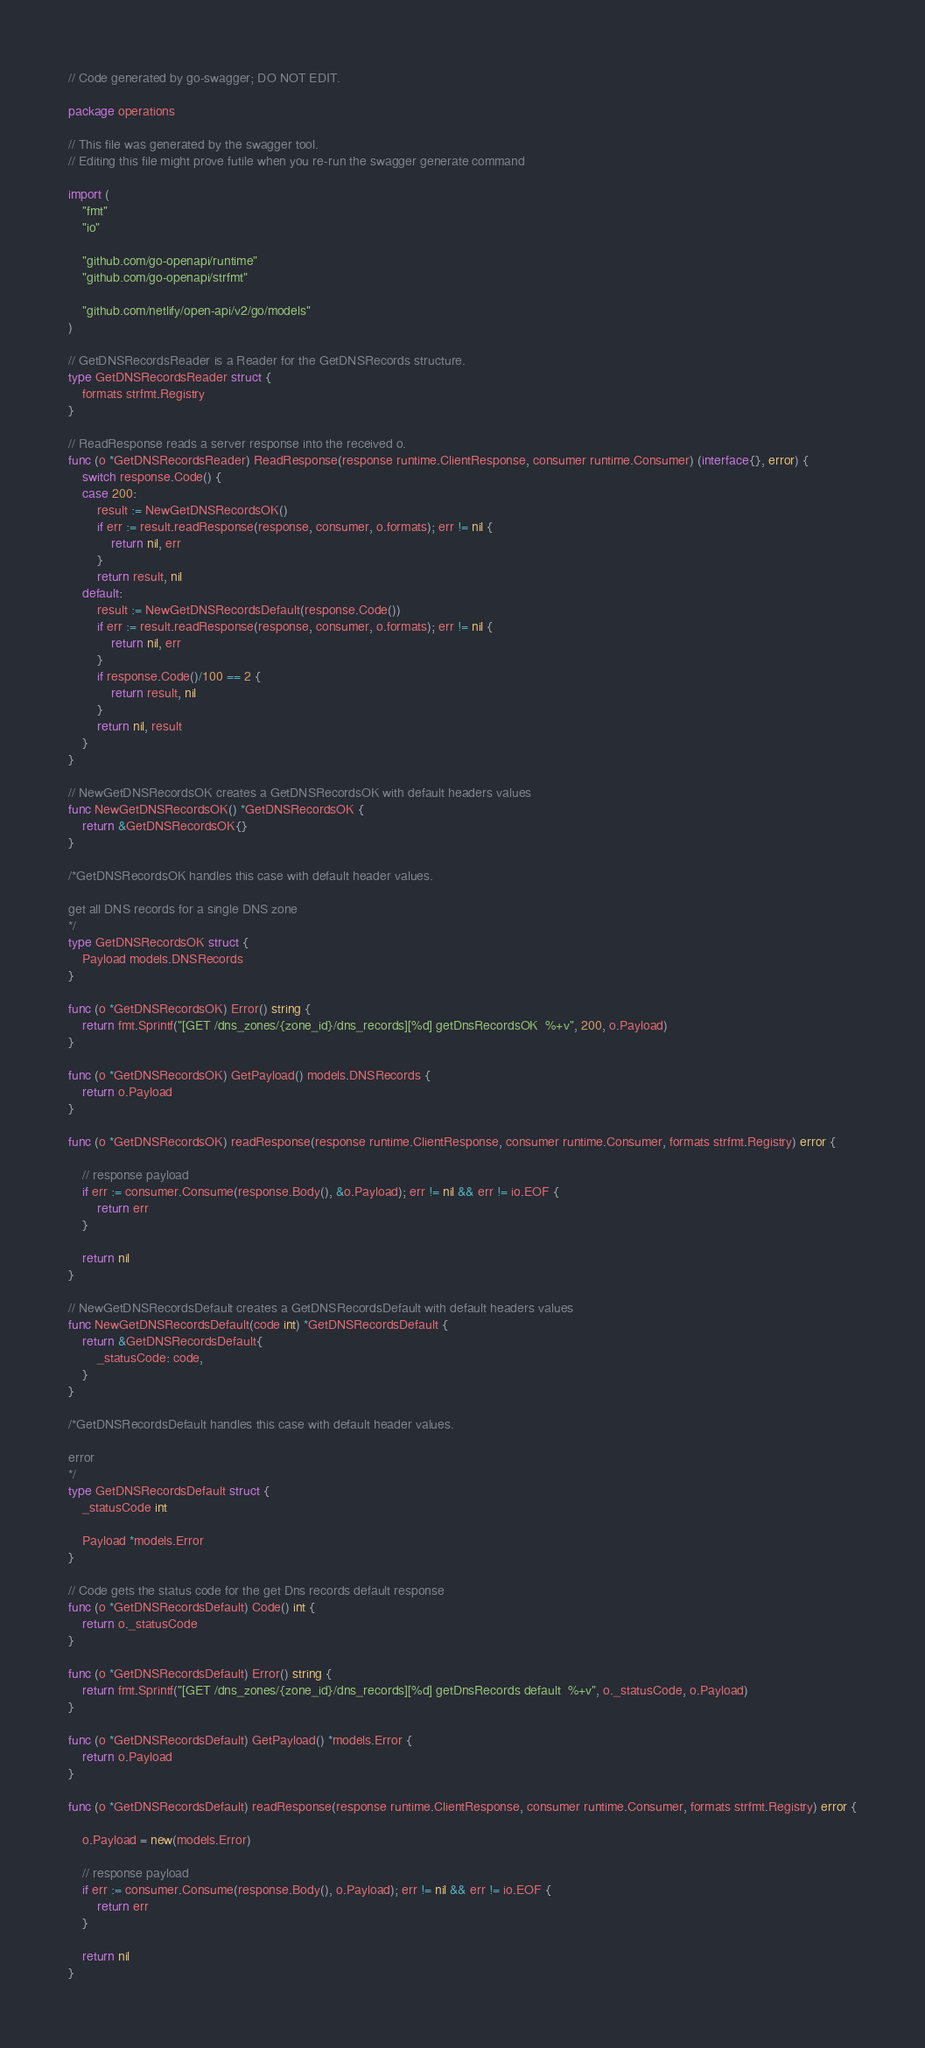<code> <loc_0><loc_0><loc_500><loc_500><_Go_>// Code generated by go-swagger; DO NOT EDIT.

package operations

// This file was generated by the swagger tool.
// Editing this file might prove futile when you re-run the swagger generate command

import (
	"fmt"
	"io"

	"github.com/go-openapi/runtime"
	"github.com/go-openapi/strfmt"

	"github.com/netlify/open-api/v2/go/models"
)

// GetDNSRecordsReader is a Reader for the GetDNSRecords structure.
type GetDNSRecordsReader struct {
	formats strfmt.Registry
}

// ReadResponse reads a server response into the received o.
func (o *GetDNSRecordsReader) ReadResponse(response runtime.ClientResponse, consumer runtime.Consumer) (interface{}, error) {
	switch response.Code() {
	case 200:
		result := NewGetDNSRecordsOK()
		if err := result.readResponse(response, consumer, o.formats); err != nil {
			return nil, err
		}
		return result, nil
	default:
		result := NewGetDNSRecordsDefault(response.Code())
		if err := result.readResponse(response, consumer, o.formats); err != nil {
			return nil, err
		}
		if response.Code()/100 == 2 {
			return result, nil
		}
		return nil, result
	}
}

// NewGetDNSRecordsOK creates a GetDNSRecordsOK with default headers values
func NewGetDNSRecordsOK() *GetDNSRecordsOK {
	return &GetDNSRecordsOK{}
}

/*GetDNSRecordsOK handles this case with default header values.

get all DNS records for a single DNS zone
*/
type GetDNSRecordsOK struct {
	Payload models.DNSRecords
}

func (o *GetDNSRecordsOK) Error() string {
	return fmt.Sprintf("[GET /dns_zones/{zone_id}/dns_records][%d] getDnsRecordsOK  %+v", 200, o.Payload)
}

func (o *GetDNSRecordsOK) GetPayload() models.DNSRecords {
	return o.Payload
}

func (o *GetDNSRecordsOK) readResponse(response runtime.ClientResponse, consumer runtime.Consumer, formats strfmt.Registry) error {

	// response payload
	if err := consumer.Consume(response.Body(), &o.Payload); err != nil && err != io.EOF {
		return err
	}

	return nil
}

// NewGetDNSRecordsDefault creates a GetDNSRecordsDefault with default headers values
func NewGetDNSRecordsDefault(code int) *GetDNSRecordsDefault {
	return &GetDNSRecordsDefault{
		_statusCode: code,
	}
}

/*GetDNSRecordsDefault handles this case with default header values.

error
*/
type GetDNSRecordsDefault struct {
	_statusCode int

	Payload *models.Error
}

// Code gets the status code for the get Dns records default response
func (o *GetDNSRecordsDefault) Code() int {
	return o._statusCode
}

func (o *GetDNSRecordsDefault) Error() string {
	return fmt.Sprintf("[GET /dns_zones/{zone_id}/dns_records][%d] getDnsRecords default  %+v", o._statusCode, o.Payload)
}

func (o *GetDNSRecordsDefault) GetPayload() *models.Error {
	return o.Payload
}

func (o *GetDNSRecordsDefault) readResponse(response runtime.ClientResponse, consumer runtime.Consumer, formats strfmt.Registry) error {

	o.Payload = new(models.Error)

	// response payload
	if err := consumer.Consume(response.Body(), o.Payload); err != nil && err != io.EOF {
		return err
	}

	return nil
}
</code> 